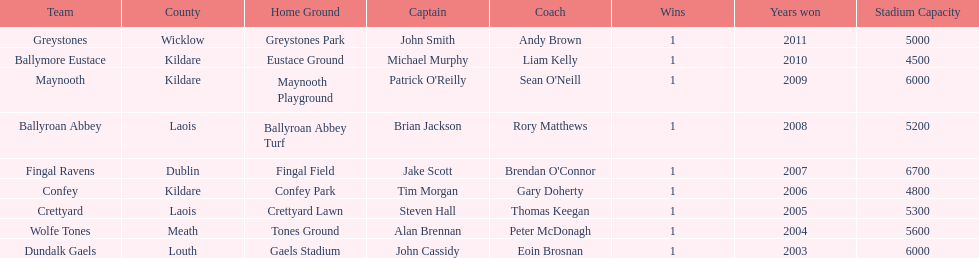What team comes before confey Fingal Ravens. 